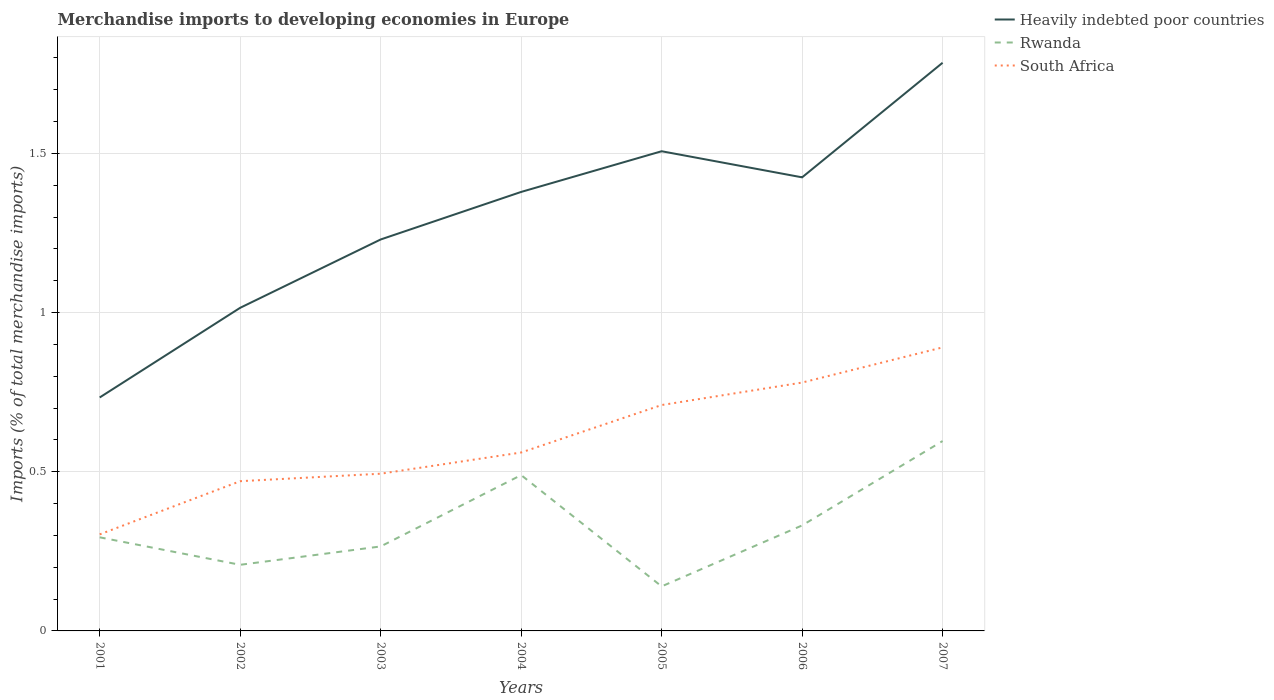Is the number of lines equal to the number of legend labels?
Your answer should be compact. Yes. Across all years, what is the maximum percentage total merchandise imports in South Africa?
Provide a short and direct response. 0.3. In which year was the percentage total merchandise imports in South Africa maximum?
Ensure brevity in your answer.  2001. What is the total percentage total merchandise imports in Heavily indebted poor countries in the graph?
Provide a succinct answer. -0.28. What is the difference between the highest and the second highest percentage total merchandise imports in Rwanda?
Offer a very short reply. 0.46. Is the percentage total merchandise imports in South Africa strictly greater than the percentage total merchandise imports in Heavily indebted poor countries over the years?
Provide a short and direct response. Yes. How many lines are there?
Give a very brief answer. 3. What is the difference between two consecutive major ticks on the Y-axis?
Your response must be concise. 0.5. Does the graph contain grids?
Provide a succinct answer. Yes. Where does the legend appear in the graph?
Make the answer very short. Top right. How many legend labels are there?
Offer a terse response. 3. How are the legend labels stacked?
Offer a terse response. Vertical. What is the title of the graph?
Offer a very short reply. Merchandise imports to developing economies in Europe. What is the label or title of the Y-axis?
Keep it short and to the point. Imports (% of total merchandise imports). What is the Imports (% of total merchandise imports) of Heavily indebted poor countries in 2001?
Provide a short and direct response. 0.73. What is the Imports (% of total merchandise imports) in Rwanda in 2001?
Provide a short and direct response. 0.29. What is the Imports (% of total merchandise imports) of South Africa in 2001?
Ensure brevity in your answer.  0.3. What is the Imports (% of total merchandise imports) in Heavily indebted poor countries in 2002?
Ensure brevity in your answer.  1.01. What is the Imports (% of total merchandise imports) in Rwanda in 2002?
Your answer should be very brief. 0.21. What is the Imports (% of total merchandise imports) of South Africa in 2002?
Your answer should be compact. 0.47. What is the Imports (% of total merchandise imports) of Heavily indebted poor countries in 2003?
Provide a succinct answer. 1.23. What is the Imports (% of total merchandise imports) in Rwanda in 2003?
Provide a short and direct response. 0.27. What is the Imports (% of total merchandise imports) in South Africa in 2003?
Provide a succinct answer. 0.49. What is the Imports (% of total merchandise imports) in Heavily indebted poor countries in 2004?
Offer a terse response. 1.38. What is the Imports (% of total merchandise imports) of Rwanda in 2004?
Your answer should be compact. 0.49. What is the Imports (% of total merchandise imports) in South Africa in 2004?
Provide a succinct answer. 0.56. What is the Imports (% of total merchandise imports) of Heavily indebted poor countries in 2005?
Make the answer very short. 1.51. What is the Imports (% of total merchandise imports) of Rwanda in 2005?
Make the answer very short. 0.14. What is the Imports (% of total merchandise imports) of South Africa in 2005?
Keep it short and to the point. 0.71. What is the Imports (% of total merchandise imports) of Heavily indebted poor countries in 2006?
Offer a very short reply. 1.42. What is the Imports (% of total merchandise imports) in Rwanda in 2006?
Ensure brevity in your answer.  0.33. What is the Imports (% of total merchandise imports) of South Africa in 2006?
Your answer should be very brief. 0.78. What is the Imports (% of total merchandise imports) of Heavily indebted poor countries in 2007?
Your answer should be very brief. 1.78. What is the Imports (% of total merchandise imports) of Rwanda in 2007?
Your answer should be very brief. 0.6. What is the Imports (% of total merchandise imports) in South Africa in 2007?
Give a very brief answer. 0.89. Across all years, what is the maximum Imports (% of total merchandise imports) of Heavily indebted poor countries?
Your response must be concise. 1.78. Across all years, what is the maximum Imports (% of total merchandise imports) of Rwanda?
Ensure brevity in your answer.  0.6. Across all years, what is the maximum Imports (% of total merchandise imports) of South Africa?
Make the answer very short. 0.89. Across all years, what is the minimum Imports (% of total merchandise imports) in Heavily indebted poor countries?
Keep it short and to the point. 0.73. Across all years, what is the minimum Imports (% of total merchandise imports) in Rwanda?
Ensure brevity in your answer.  0.14. Across all years, what is the minimum Imports (% of total merchandise imports) in South Africa?
Your response must be concise. 0.3. What is the total Imports (% of total merchandise imports) of Heavily indebted poor countries in the graph?
Provide a short and direct response. 9.07. What is the total Imports (% of total merchandise imports) of Rwanda in the graph?
Offer a very short reply. 2.32. What is the total Imports (% of total merchandise imports) in South Africa in the graph?
Your answer should be very brief. 4.21. What is the difference between the Imports (% of total merchandise imports) in Heavily indebted poor countries in 2001 and that in 2002?
Keep it short and to the point. -0.28. What is the difference between the Imports (% of total merchandise imports) of Rwanda in 2001 and that in 2002?
Make the answer very short. 0.09. What is the difference between the Imports (% of total merchandise imports) in South Africa in 2001 and that in 2002?
Your answer should be very brief. -0.17. What is the difference between the Imports (% of total merchandise imports) in Heavily indebted poor countries in 2001 and that in 2003?
Your response must be concise. -0.5. What is the difference between the Imports (% of total merchandise imports) of Rwanda in 2001 and that in 2003?
Your answer should be compact. 0.03. What is the difference between the Imports (% of total merchandise imports) of South Africa in 2001 and that in 2003?
Provide a short and direct response. -0.19. What is the difference between the Imports (% of total merchandise imports) in Heavily indebted poor countries in 2001 and that in 2004?
Make the answer very short. -0.65. What is the difference between the Imports (% of total merchandise imports) in Rwanda in 2001 and that in 2004?
Your answer should be very brief. -0.2. What is the difference between the Imports (% of total merchandise imports) in South Africa in 2001 and that in 2004?
Your answer should be very brief. -0.26. What is the difference between the Imports (% of total merchandise imports) of Heavily indebted poor countries in 2001 and that in 2005?
Offer a very short reply. -0.77. What is the difference between the Imports (% of total merchandise imports) of Rwanda in 2001 and that in 2005?
Offer a very short reply. 0.15. What is the difference between the Imports (% of total merchandise imports) in South Africa in 2001 and that in 2005?
Provide a succinct answer. -0.41. What is the difference between the Imports (% of total merchandise imports) in Heavily indebted poor countries in 2001 and that in 2006?
Provide a short and direct response. -0.69. What is the difference between the Imports (% of total merchandise imports) in Rwanda in 2001 and that in 2006?
Give a very brief answer. -0.04. What is the difference between the Imports (% of total merchandise imports) in South Africa in 2001 and that in 2006?
Keep it short and to the point. -0.48. What is the difference between the Imports (% of total merchandise imports) in Heavily indebted poor countries in 2001 and that in 2007?
Make the answer very short. -1.05. What is the difference between the Imports (% of total merchandise imports) of Rwanda in 2001 and that in 2007?
Provide a short and direct response. -0.3. What is the difference between the Imports (% of total merchandise imports) of South Africa in 2001 and that in 2007?
Ensure brevity in your answer.  -0.59. What is the difference between the Imports (% of total merchandise imports) of Heavily indebted poor countries in 2002 and that in 2003?
Provide a succinct answer. -0.21. What is the difference between the Imports (% of total merchandise imports) of Rwanda in 2002 and that in 2003?
Offer a terse response. -0.06. What is the difference between the Imports (% of total merchandise imports) of South Africa in 2002 and that in 2003?
Your response must be concise. -0.02. What is the difference between the Imports (% of total merchandise imports) of Heavily indebted poor countries in 2002 and that in 2004?
Offer a very short reply. -0.36. What is the difference between the Imports (% of total merchandise imports) of Rwanda in 2002 and that in 2004?
Your response must be concise. -0.28. What is the difference between the Imports (% of total merchandise imports) in South Africa in 2002 and that in 2004?
Provide a short and direct response. -0.09. What is the difference between the Imports (% of total merchandise imports) of Heavily indebted poor countries in 2002 and that in 2005?
Your answer should be very brief. -0.49. What is the difference between the Imports (% of total merchandise imports) in Rwanda in 2002 and that in 2005?
Provide a short and direct response. 0.07. What is the difference between the Imports (% of total merchandise imports) in South Africa in 2002 and that in 2005?
Ensure brevity in your answer.  -0.24. What is the difference between the Imports (% of total merchandise imports) of Heavily indebted poor countries in 2002 and that in 2006?
Ensure brevity in your answer.  -0.41. What is the difference between the Imports (% of total merchandise imports) in Rwanda in 2002 and that in 2006?
Give a very brief answer. -0.12. What is the difference between the Imports (% of total merchandise imports) in South Africa in 2002 and that in 2006?
Provide a succinct answer. -0.31. What is the difference between the Imports (% of total merchandise imports) of Heavily indebted poor countries in 2002 and that in 2007?
Provide a short and direct response. -0.77. What is the difference between the Imports (% of total merchandise imports) of Rwanda in 2002 and that in 2007?
Your response must be concise. -0.39. What is the difference between the Imports (% of total merchandise imports) of South Africa in 2002 and that in 2007?
Provide a succinct answer. -0.42. What is the difference between the Imports (% of total merchandise imports) of Heavily indebted poor countries in 2003 and that in 2004?
Offer a terse response. -0.15. What is the difference between the Imports (% of total merchandise imports) of Rwanda in 2003 and that in 2004?
Make the answer very short. -0.22. What is the difference between the Imports (% of total merchandise imports) in South Africa in 2003 and that in 2004?
Your response must be concise. -0.07. What is the difference between the Imports (% of total merchandise imports) of Heavily indebted poor countries in 2003 and that in 2005?
Provide a short and direct response. -0.28. What is the difference between the Imports (% of total merchandise imports) in Rwanda in 2003 and that in 2005?
Provide a succinct answer. 0.13. What is the difference between the Imports (% of total merchandise imports) of South Africa in 2003 and that in 2005?
Provide a short and direct response. -0.22. What is the difference between the Imports (% of total merchandise imports) in Heavily indebted poor countries in 2003 and that in 2006?
Ensure brevity in your answer.  -0.2. What is the difference between the Imports (% of total merchandise imports) of Rwanda in 2003 and that in 2006?
Your answer should be compact. -0.07. What is the difference between the Imports (% of total merchandise imports) of South Africa in 2003 and that in 2006?
Your answer should be compact. -0.29. What is the difference between the Imports (% of total merchandise imports) in Heavily indebted poor countries in 2003 and that in 2007?
Give a very brief answer. -0.56. What is the difference between the Imports (% of total merchandise imports) of Rwanda in 2003 and that in 2007?
Offer a terse response. -0.33. What is the difference between the Imports (% of total merchandise imports) in South Africa in 2003 and that in 2007?
Ensure brevity in your answer.  -0.4. What is the difference between the Imports (% of total merchandise imports) in Heavily indebted poor countries in 2004 and that in 2005?
Your response must be concise. -0.13. What is the difference between the Imports (% of total merchandise imports) of Rwanda in 2004 and that in 2005?
Your answer should be compact. 0.35. What is the difference between the Imports (% of total merchandise imports) of South Africa in 2004 and that in 2005?
Make the answer very short. -0.15. What is the difference between the Imports (% of total merchandise imports) in Heavily indebted poor countries in 2004 and that in 2006?
Offer a terse response. -0.05. What is the difference between the Imports (% of total merchandise imports) in Rwanda in 2004 and that in 2006?
Provide a short and direct response. 0.16. What is the difference between the Imports (% of total merchandise imports) in South Africa in 2004 and that in 2006?
Offer a very short reply. -0.22. What is the difference between the Imports (% of total merchandise imports) in Heavily indebted poor countries in 2004 and that in 2007?
Offer a very short reply. -0.41. What is the difference between the Imports (% of total merchandise imports) of Rwanda in 2004 and that in 2007?
Offer a very short reply. -0.11. What is the difference between the Imports (% of total merchandise imports) of South Africa in 2004 and that in 2007?
Offer a very short reply. -0.33. What is the difference between the Imports (% of total merchandise imports) in Heavily indebted poor countries in 2005 and that in 2006?
Provide a short and direct response. 0.08. What is the difference between the Imports (% of total merchandise imports) in Rwanda in 2005 and that in 2006?
Your answer should be very brief. -0.19. What is the difference between the Imports (% of total merchandise imports) of South Africa in 2005 and that in 2006?
Give a very brief answer. -0.07. What is the difference between the Imports (% of total merchandise imports) of Heavily indebted poor countries in 2005 and that in 2007?
Give a very brief answer. -0.28. What is the difference between the Imports (% of total merchandise imports) of Rwanda in 2005 and that in 2007?
Offer a very short reply. -0.46. What is the difference between the Imports (% of total merchandise imports) of South Africa in 2005 and that in 2007?
Provide a succinct answer. -0.18. What is the difference between the Imports (% of total merchandise imports) of Heavily indebted poor countries in 2006 and that in 2007?
Provide a short and direct response. -0.36. What is the difference between the Imports (% of total merchandise imports) of Rwanda in 2006 and that in 2007?
Offer a very short reply. -0.27. What is the difference between the Imports (% of total merchandise imports) in South Africa in 2006 and that in 2007?
Give a very brief answer. -0.11. What is the difference between the Imports (% of total merchandise imports) in Heavily indebted poor countries in 2001 and the Imports (% of total merchandise imports) in Rwanda in 2002?
Your answer should be compact. 0.53. What is the difference between the Imports (% of total merchandise imports) in Heavily indebted poor countries in 2001 and the Imports (% of total merchandise imports) in South Africa in 2002?
Provide a short and direct response. 0.26. What is the difference between the Imports (% of total merchandise imports) in Rwanda in 2001 and the Imports (% of total merchandise imports) in South Africa in 2002?
Offer a very short reply. -0.18. What is the difference between the Imports (% of total merchandise imports) in Heavily indebted poor countries in 2001 and the Imports (% of total merchandise imports) in Rwanda in 2003?
Offer a very short reply. 0.47. What is the difference between the Imports (% of total merchandise imports) in Heavily indebted poor countries in 2001 and the Imports (% of total merchandise imports) in South Africa in 2003?
Your answer should be compact. 0.24. What is the difference between the Imports (% of total merchandise imports) in Rwanda in 2001 and the Imports (% of total merchandise imports) in South Africa in 2003?
Provide a short and direct response. -0.2. What is the difference between the Imports (% of total merchandise imports) in Heavily indebted poor countries in 2001 and the Imports (% of total merchandise imports) in Rwanda in 2004?
Give a very brief answer. 0.24. What is the difference between the Imports (% of total merchandise imports) of Heavily indebted poor countries in 2001 and the Imports (% of total merchandise imports) of South Africa in 2004?
Give a very brief answer. 0.17. What is the difference between the Imports (% of total merchandise imports) in Rwanda in 2001 and the Imports (% of total merchandise imports) in South Africa in 2004?
Your answer should be very brief. -0.27. What is the difference between the Imports (% of total merchandise imports) in Heavily indebted poor countries in 2001 and the Imports (% of total merchandise imports) in Rwanda in 2005?
Keep it short and to the point. 0.59. What is the difference between the Imports (% of total merchandise imports) of Heavily indebted poor countries in 2001 and the Imports (% of total merchandise imports) of South Africa in 2005?
Provide a succinct answer. 0.02. What is the difference between the Imports (% of total merchandise imports) in Rwanda in 2001 and the Imports (% of total merchandise imports) in South Africa in 2005?
Offer a terse response. -0.42. What is the difference between the Imports (% of total merchandise imports) in Heavily indebted poor countries in 2001 and the Imports (% of total merchandise imports) in Rwanda in 2006?
Your response must be concise. 0.4. What is the difference between the Imports (% of total merchandise imports) of Heavily indebted poor countries in 2001 and the Imports (% of total merchandise imports) of South Africa in 2006?
Offer a terse response. -0.05. What is the difference between the Imports (% of total merchandise imports) in Rwanda in 2001 and the Imports (% of total merchandise imports) in South Africa in 2006?
Provide a succinct answer. -0.49. What is the difference between the Imports (% of total merchandise imports) in Heavily indebted poor countries in 2001 and the Imports (% of total merchandise imports) in Rwanda in 2007?
Offer a terse response. 0.14. What is the difference between the Imports (% of total merchandise imports) of Heavily indebted poor countries in 2001 and the Imports (% of total merchandise imports) of South Africa in 2007?
Ensure brevity in your answer.  -0.16. What is the difference between the Imports (% of total merchandise imports) in Rwanda in 2001 and the Imports (% of total merchandise imports) in South Africa in 2007?
Offer a very short reply. -0.6. What is the difference between the Imports (% of total merchandise imports) in Heavily indebted poor countries in 2002 and the Imports (% of total merchandise imports) in Rwanda in 2003?
Offer a very short reply. 0.75. What is the difference between the Imports (% of total merchandise imports) of Heavily indebted poor countries in 2002 and the Imports (% of total merchandise imports) of South Africa in 2003?
Offer a very short reply. 0.52. What is the difference between the Imports (% of total merchandise imports) in Rwanda in 2002 and the Imports (% of total merchandise imports) in South Africa in 2003?
Make the answer very short. -0.29. What is the difference between the Imports (% of total merchandise imports) in Heavily indebted poor countries in 2002 and the Imports (% of total merchandise imports) in Rwanda in 2004?
Provide a short and direct response. 0.53. What is the difference between the Imports (% of total merchandise imports) in Heavily indebted poor countries in 2002 and the Imports (% of total merchandise imports) in South Africa in 2004?
Offer a very short reply. 0.45. What is the difference between the Imports (% of total merchandise imports) in Rwanda in 2002 and the Imports (% of total merchandise imports) in South Africa in 2004?
Make the answer very short. -0.35. What is the difference between the Imports (% of total merchandise imports) of Heavily indebted poor countries in 2002 and the Imports (% of total merchandise imports) of Rwanda in 2005?
Provide a succinct answer. 0.88. What is the difference between the Imports (% of total merchandise imports) of Heavily indebted poor countries in 2002 and the Imports (% of total merchandise imports) of South Africa in 2005?
Ensure brevity in your answer.  0.31. What is the difference between the Imports (% of total merchandise imports) of Rwanda in 2002 and the Imports (% of total merchandise imports) of South Africa in 2005?
Provide a short and direct response. -0.5. What is the difference between the Imports (% of total merchandise imports) of Heavily indebted poor countries in 2002 and the Imports (% of total merchandise imports) of Rwanda in 2006?
Offer a terse response. 0.68. What is the difference between the Imports (% of total merchandise imports) of Heavily indebted poor countries in 2002 and the Imports (% of total merchandise imports) of South Africa in 2006?
Offer a terse response. 0.23. What is the difference between the Imports (% of total merchandise imports) in Rwanda in 2002 and the Imports (% of total merchandise imports) in South Africa in 2006?
Your answer should be very brief. -0.57. What is the difference between the Imports (% of total merchandise imports) of Heavily indebted poor countries in 2002 and the Imports (% of total merchandise imports) of Rwanda in 2007?
Provide a short and direct response. 0.42. What is the difference between the Imports (% of total merchandise imports) of Heavily indebted poor countries in 2002 and the Imports (% of total merchandise imports) of South Africa in 2007?
Offer a very short reply. 0.12. What is the difference between the Imports (% of total merchandise imports) in Rwanda in 2002 and the Imports (% of total merchandise imports) in South Africa in 2007?
Provide a succinct answer. -0.68. What is the difference between the Imports (% of total merchandise imports) in Heavily indebted poor countries in 2003 and the Imports (% of total merchandise imports) in Rwanda in 2004?
Provide a short and direct response. 0.74. What is the difference between the Imports (% of total merchandise imports) in Heavily indebted poor countries in 2003 and the Imports (% of total merchandise imports) in South Africa in 2004?
Keep it short and to the point. 0.67. What is the difference between the Imports (% of total merchandise imports) of Rwanda in 2003 and the Imports (% of total merchandise imports) of South Africa in 2004?
Make the answer very short. -0.3. What is the difference between the Imports (% of total merchandise imports) in Heavily indebted poor countries in 2003 and the Imports (% of total merchandise imports) in Rwanda in 2005?
Give a very brief answer. 1.09. What is the difference between the Imports (% of total merchandise imports) of Heavily indebted poor countries in 2003 and the Imports (% of total merchandise imports) of South Africa in 2005?
Your response must be concise. 0.52. What is the difference between the Imports (% of total merchandise imports) in Rwanda in 2003 and the Imports (% of total merchandise imports) in South Africa in 2005?
Your response must be concise. -0.44. What is the difference between the Imports (% of total merchandise imports) of Heavily indebted poor countries in 2003 and the Imports (% of total merchandise imports) of Rwanda in 2006?
Give a very brief answer. 0.9. What is the difference between the Imports (% of total merchandise imports) in Heavily indebted poor countries in 2003 and the Imports (% of total merchandise imports) in South Africa in 2006?
Your answer should be compact. 0.45. What is the difference between the Imports (% of total merchandise imports) in Rwanda in 2003 and the Imports (% of total merchandise imports) in South Africa in 2006?
Offer a very short reply. -0.51. What is the difference between the Imports (% of total merchandise imports) of Heavily indebted poor countries in 2003 and the Imports (% of total merchandise imports) of Rwanda in 2007?
Your answer should be very brief. 0.63. What is the difference between the Imports (% of total merchandise imports) of Heavily indebted poor countries in 2003 and the Imports (% of total merchandise imports) of South Africa in 2007?
Make the answer very short. 0.34. What is the difference between the Imports (% of total merchandise imports) of Rwanda in 2003 and the Imports (% of total merchandise imports) of South Africa in 2007?
Your answer should be very brief. -0.63. What is the difference between the Imports (% of total merchandise imports) in Heavily indebted poor countries in 2004 and the Imports (% of total merchandise imports) in Rwanda in 2005?
Provide a short and direct response. 1.24. What is the difference between the Imports (% of total merchandise imports) of Heavily indebted poor countries in 2004 and the Imports (% of total merchandise imports) of South Africa in 2005?
Your response must be concise. 0.67. What is the difference between the Imports (% of total merchandise imports) in Rwanda in 2004 and the Imports (% of total merchandise imports) in South Africa in 2005?
Your answer should be compact. -0.22. What is the difference between the Imports (% of total merchandise imports) of Heavily indebted poor countries in 2004 and the Imports (% of total merchandise imports) of Rwanda in 2006?
Give a very brief answer. 1.05. What is the difference between the Imports (% of total merchandise imports) in Heavily indebted poor countries in 2004 and the Imports (% of total merchandise imports) in South Africa in 2006?
Ensure brevity in your answer.  0.6. What is the difference between the Imports (% of total merchandise imports) of Rwanda in 2004 and the Imports (% of total merchandise imports) of South Africa in 2006?
Ensure brevity in your answer.  -0.29. What is the difference between the Imports (% of total merchandise imports) in Heavily indebted poor countries in 2004 and the Imports (% of total merchandise imports) in Rwanda in 2007?
Offer a very short reply. 0.78. What is the difference between the Imports (% of total merchandise imports) of Heavily indebted poor countries in 2004 and the Imports (% of total merchandise imports) of South Africa in 2007?
Your answer should be very brief. 0.49. What is the difference between the Imports (% of total merchandise imports) in Rwanda in 2004 and the Imports (% of total merchandise imports) in South Africa in 2007?
Your answer should be compact. -0.4. What is the difference between the Imports (% of total merchandise imports) of Heavily indebted poor countries in 2005 and the Imports (% of total merchandise imports) of Rwanda in 2006?
Ensure brevity in your answer.  1.18. What is the difference between the Imports (% of total merchandise imports) in Heavily indebted poor countries in 2005 and the Imports (% of total merchandise imports) in South Africa in 2006?
Give a very brief answer. 0.73. What is the difference between the Imports (% of total merchandise imports) of Rwanda in 2005 and the Imports (% of total merchandise imports) of South Africa in 2006?
Provide a succinct answer. -0.64. What is the difference between the Imports (% of total merchandise imports) in Heavily indebted poor countries in 2005 and the Imports (% of total merchandise imports) in Rwanda in 2007?
Offer a very short reply. 0.91. What is the difference between the Imports (% of total merchandise imports) of Heavily indebted poor countries in 2005 and the Imports (% of total merchandise imports) of South Africa in 2007?
Give a very brief answer. 0.62. What is the difference between the Imports (% of total merchandise imports) in Rwanda in 2005 and the Imports (% of total merchandise imports) in South Africa in 2007?
Ensure brevity in your answer.  -0.75. What is the difference between the Imports (% of total merchandise imports) of Heavily indebted poor countries in 2006 and the Imports (% of total merchandise imports) of Rwanda in 2007?
Ensure brevity in your answer.  0.83. What is the difference between the Imports (% of total merchandise imports) in Heavily indebted poor countries in 2006 and the Imports (% of total merchandise imports) in South Africa in 2007?
Offer a very short reply. 0.53. What is the difference between the Imports (% of total merchandise imports) in Rwanda in 2006 and the Imports (% of total merchandise imports) in South Africa in 2007?
Ensure brevity in your answer.  -0.56. What is the average Imports (% of total merchandise imports) in Heavily indebted poor countries per year?
Offer a terse response. 1.3. What is the average Imports (% of total merchandise imports) in Rwanda per year?
Offer a very short reply. 0.33. What is the average Imports (% of total merchandise imports) of South Africa per year?
Ensure brevity in your answer.  0.6. In the year 2001, what is the difference between the Imports (% of total merchandise imports) of Heavily indebted poor countries and Imports (% of total merchandise imports) of Rwanda?
Ensure brevity in your answer.  0.44. In the year 2001, what is the difference between the Imports (% of total merchandise imports) of Heavily indebted poor countries and Imports (% of total merchandise imports) of South Africa?
Your answer should be very brief. 0.43. In the year 2001, what is the difference between the Imports (% of total merchandise imports) in Rwanda and Imports (% of total merchandise imports) in South Africa?
Ensure brevity in your answer.  -0.01. In the year 2002, what is the difference between the Imports (% of total merchandise imports) of Heavily indebted poor countries and Imports (% of total merchandise imports) of Rwanda?
Ensure brevity in your answer.  0.81. In the year 2002, what is the difference between the Imports (% of total merchandise imports) of Heavily indebted poor countries and Imports (% of total merchandise imports) of South Africa?
Offer a terse response. 0.54. In the year 2002, what is the difference between the Imports (% of total merchandise imports) of Rwanda and Imports (% of total merchandise imports) of South Africa?
Offer a very short reply. -0.26. In the year 2003, what is the difference between the Imports (% of total merchandise imports) of Heavily indebted poor countries and Imports (% of total merchandise imports) of Rwanda?
Make the answer very short. 0.96. In the year 2003, what is the difference between the Imports (% of total merchandise imports) in Heavily indebted poor countries and Imports (% of total merchandise imports) in South Africa?
Provide a succinct answer. 0.74. In the year 2003, what is the difference between the Imports (% of total merchandise imports) of Rwanda and Imports (% of total merchandise imports) of South Africa?
Ensure brevity in your answer.  -0.23. In the year 2004, what is the difference between the Imports (% of total merchandise imports) of Heavily indebted poor countries and Imports (% of total merchandise imports) of Rwanda?
Offer a terse response. 0.89. In the year 2004, what is the difference between the Imports (% of total merchandise imports) in Heavily indebted poor countries and Imports (% of total merchandise imports) in South Africa?
Make the answer very short. 0.82. In the year 2004, what is the difference between the Imports (% of total merchandise imports) of Rwanda and Imports (% of total merchandise imports) of South Africa?
Make the answer very short. -0.07. In the year 2005, what is the difference between the Imports (% of total merchandise imports) in Heavily indebted poor countries and Imports (% of total merchandise imports) in Rwanda?
Your answer should be very brief. 1.37. In the year 2005, what is the difference between the Imports (% of total merchandise imports) of Heavily indebted poor countries and Imports (% of total merchandise imports) of South Africa?
Keep it short and to the point. 0.8. In the year 2005, what is the difference between the Imports (% of total merchandise imports) in Rwanda and Imports (% of total merchandise imports) in South Africa?
Your answer should be compact. -0.57. In the year 2006, what is the difference between the Imports (% of total merchandise imports) in Heavily indebted poor countries and Imports (% of total merchandise imports) in Rwanda?
Give a very brief answer. 1.09. In the year 2006, what is the difference between the Imports (% of total merchandise imports) in Heavily indebted poor countries and Imports (% of total merchandise imports) in South Africa?
Your answer should be very brief. 0.64. In the year 2006, what is the difference between the Imports (% of total merchandise imports) in Rwanda and Imports (% of total merchandise imports) in South Africa?
Offer a terse response. -0.45. In the year 2007, what is the difference between the Imports (% of total merchandise imports) in Heavily indebted poor countries and Imports (% of total merchandise imports) in Rwanda?
Offer a very short reply. 1.19. In the year 2007, what is the difference between the Imports (% of total merchandise imports) of Heavily indebted poor countries and Imports (% of total merchandise imports) of South Africa?
Ensure brevity in your answer.  0.89. In the year 2007, what is the difference between the Imports (% of total merchandise imports) of Rwanda and Imports (% of total merchandise imports) of South Africa?
Keep it short and to the point. -0.29. What is the ratio of the Imports (% of total merchandise imports) of Heavily indebted poor countries in 2001 to that in 2002?
Your answer should be compact. 0.72. What is the ratio of the Imports (% of total merchandise imports) of Rwanda in 2001 to that in 2002?
Offer a terse response. 1.42. What is the ratio of the Imports (% of total merchandise imports) of South Africa in 2001 to that in 2002?
Ensure brevity in your answer.  0.64. What is the ratio of the Imports (% of total merchandise imports) of Heavily indebted poor countries in 2001 to that in 2003?
Your answer should be very brief. 0.6. What is the ratio of the Imports (% of total merchandise imports) of Rwanda in 2001 to that in 2003?
Keep it short and to the point. 1.11. What is the ratio of the Imports (% of total merchandise imports) in South Africa in 2001 to that in 2003?
Your answer should be compact. 0.61. What is the ratio of the Imports (% of total merchandise imports) in Heavily indebted poor countries in 2001 to that in 2004?
Give a very brief answer. 0.53. What is the ratio of the Imports (% of total merchandise imports) of Rwanda in 2001 to that in 2004?
Provide a short and direct response. 0.6. What is the ratio of the Imports (% of total merchandise imports) in South Africa in 2001 to that in 2004?
Ensure brevity in your answer.  0.54. What is the ratio of the Imports (% of total merchandise imports) of Heavily indebted poor countries in 2001 to that in 2005?
Offer a very short reply. 0.49. What is the ratio of the Imports (% of total merchandise imports) of Rwanda in 2001 to that in 2005?
Your answer should be compact. 2.1. What is the ratio of the Imports (% of total merchandise imports) in South Africa in 2001 to that in 2005?
Provide a succinct answer. 0.43. What is the ratio of the Imports (% of total merchandise imports) in Heavily indebted poor countries in 2001 to that in 2006?
Your answer should be compact. 0.51. What is the ratio of the Imports (% of total merchandise imports) in Rwanda in 2001 to that in 2006?
Ensure brevity in your answer.  0.89. What is the ratio of the Imports (% of total merchandise imports) in South Africa in 2001 to that in 2006?
Your answer should be very brief. 0.39. What is the ratio of the Imports (% of total merchandise imports) in Heavily indebted poor countries in 2001 to that in 2007?
Your answer should be compact. 0.41. What is the ratio of the Imports (% of total merchandise imports) of Rwanda in 2001 to that in 2007?
Your response must be concise. 0.49. What is the ratio of the Imports (% of total merchandise imports) of South Africa in 2001 to that in 2007?
Provide a succinct answer. 0.34. What is the ratio of the Imports (% of total merchandise imports) of Heavily indebted poor countries in 2002 to that in 2003?
Provide a succinct answer. 0.83. What is the ratio of the Imports (% of total merchandise imports) of Rwanda in 2002 to that in 2003?
Your answer should be compact. 0.78. What is the ratio of the Imports (% of total merchandise imports) of South Africa in 2002 to that in 2003?
Ensure brevity in your answer.  0.95. What is the ratio of the Imports (% of total merchandise imports) in Heavily indebted poor countries in 2002 to that in 2004?
Ensure brevity in your answer.  0.74. What is the ratio of the Imports (% of total merchandise imports) in Rwanda in 2002 to that in 2004?
Your answer should be very brief. 0.42. What is the ratio of the Imports (% of total merchandise imports) in South Africa in 2002 to that in 2004?
Give a very brief answer. 0.84. What is the ratio of the Imports (% of total merchandise imports) of Heavily indebted poor countries in 2002 to that in 2005?
Your answer should be very brief. 0.67. What is the ratio of the Imports (% of total merchandise imports) in Rwanda in 2002 to that in 2005?
Keep it short and to the point. 1.48. What is the ratio of the Imports (% of total merchandise imports) of South Africa in 2002 to that in 2005?
Offer a terse response. 0.66. What is the ratio of the Imports (% of total merchandise imports) of Heavily indebted poor countries in 2002 to that in 2006?
Your answer should be compact. 0.71. What is the ratio of the Imports (% of total merchandise imports) in Rwanda in 2002 to that in 2006?
Offer a terse response. 0.63. What is the ratio of the Imports (% of total merchandise imports) in South Africa in 2002 to that in 2006?
Offer a very short reply. 0.6. What is the ratio of the Imports (% of total merchandise imports) in Heavily indebted poor countries in 2002 to that in 2007?
Your response must be concise. 0.57. What is the ratio of the Imports (% of total merchandise imports) of Rwanda in 2002 to that in 2007?
Make the answer very short. 0.35. What is the ratio of the Imports (% of total merchandise imports) of South Africa in 2002 to that in 2007?
Your answer should be compact. 0.53. What is the ratio of the Imports (% of total merchandise imports) of Heavily indebted poor countries in 2003 to that in 2004?
Provide a short and direct response. 0.89. What is the ratio of the Imports (% of total merchandise imports) of Rwanda in 2003 to that in 2004?
Give a very brief answer. 0.54. What is the ratio of the Imports (% of total merchandise imports) in South Africa in 2003 to that in 2004?
Offer a terse response. 0.88. What is the ratio of the Imports (% of total merchandise imports) of Heavily indebted poor countries in 2003 to that in 2005?
Offer a terse response. 0.82. What is the ratio of the Imports (% of total merchandise imports) in Rwanda in 2003 to that in 2005?
Provide a short and direct response. 1.9. What is the ratio of the Imports (% of total merchandise imports) of South Africa in 2003 to that in 2005?
Your answer should be very brief. 0.7. What is the ratio of the Imports (% of total merchandise imports) in Heavily indebted poor countries in 2003 to that in 2006?
Provide a succinct answer. 0.86. What is the ratio of the Imports (% of total merchandise imports) in Rwanda in 2003 to that in 2006?
Offer a terse response. 0.8. What is the ratio of the Imports (% of total merchandise imports) of South Africa in 2003 to that in 2006?
Ensure brevity in your answer.  0.63. What is the ratio of the Imports (% of total merchandise imports) in Heavily indebted poor countries in 2003 to that in 2007?
Provide a short and direct response. 0.69. What is the ratio of the Imports (% of total merchandise imports) of Rwanda in 2003 to that in 2007?
Give a very brief answer. 0.44. What is the ratio of the Imports (% of total merchandise imports) of South Africa in 2003 to that in 2007?
Your answer should be compact. 0.55. What is the ratio of the Imports (% of total merchandise imports) of Heavily indebted poor countries in 2004 to that in 2005?
Your answer should be very brief. 0.92. What is the ratio of the Imports (% of total merchandise imports) in Rwanda in 2004 to that in 2005?
Your answer should be compact. 3.5. What is the ratio of the Imports (% of total merchandise imports) of South Africa in 2004 to that in 2005?
Provide a succinct answer. 0.79. What is the ratio of the Imports (% of total merchandise imports) in Heavily indebted poor countries in 2004 to that in 2006?
Your answer should be very brief. 0.97. What is the ratio of the Imports (% of total merchandise imports) in Rwanda in 2004 to that in 2006?
Your response must be concise. 1.48. What is the ratio of the Imports (% of total merchandise imports) in South Africa in 2004 to that in 2006?
Provide a succinct answer. 0.72. What is the ratio of the Imports (% of total merchandise imports) of Heavily indebted poor countries in 2004 to that in 2007?
Give a very brief answer. 0.77. What is the ratio of the Imports (% of total merchandise imports) in Rwanda in 2004 to that in 2007?
Make the answer very short. 0.82. What is the ratio of the Imports (% of total merchandise imports) in South Africa in 2004 to that in 2007?
Your answer should be very brief. 0.63. What is the ratio of the Imports (% of total merchandise imports) in Heavily indebted poor countries in 2005 to that in 2006?
Provide a succinct answer. 1.06. What is the ratio of the Imports (% of total merchandise imports) in Rwanda in 2005 to that in 2006?
Your answer should be compact. 0.42. What is the ratio of the Imports (% of total merchandise imports) of South Africa in 2005 to that in 2006?
Make the answer very short. 0.91. What is the ratio of the Imports (% of total merchandise imports) in Heavily indebted poor countries in 2005 to that in 2007?
Your response must be concise. 0.84. What is the ratio of the Imports (% of total merchandise imports) of Rwanda in 2005 to that in 2007?
Your response must be concise. 0.23. What is the ratio of the Imports (% of total merchandise imports) in South Africa in 2005 to that in 2007?
Keep it short and to the point. 0.8. What is the ratio of the Imports (% of total merchandise imports) of Heavily indebted poor countries in 2006 to that in 2007?
Make the answer very short. 0.8. What is the ratio of the Imports (% of total merchandise imports) of Rwanda in 2006 to that in 2007?
Your answer should be very brief. 0.56. What is the ratio of the Imports (% of total merchandise imports) in South Africa in 2006 to that in 2007?
Give a very brief answer. 0.88. What is the difference between the highest and the second highest Imports (% of total merchandise imports) of Heavily indebted poor countries?
Provide a short and direct response. 0.28. What is the difference between the highest and the second highest Imports (% of total merchandise imports) of Rwanda?
Your answer should be compact. 0.11. What is the difference between the highest and the second highest Imports (% of total merchandise imports) in South Africa?
Your response must be concise. 0.11. What is the difference between the highest and the lowest Imports (% of total merchandise imports) in Heavily indebted poor countries?
Keep it short and to the point. 1.05. What is the difference between the highest and the lowest Imports (% of total merchandise imports) of Rwanda?
Keep it short and to the point. 0.46. What is the difference between the highest and the lowest Imports (% of total merchandise imports) of South Africa?
Give a very brief answer. 0.59. 